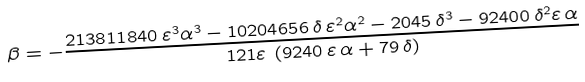Convert formula to latex. <formula><loc_0><loc_0><loc_500><loc_500>\beta = - { \frac { 2 1 3 8 1 1 8 4 0 \, { \varepsilon } ^ { 3 } { \alpha } ^ { 3 } - 1 0 2 0 4 6 5 6 \, \delta \, { \varepsilon } ^ { 2 } { \alpha } ^ { 2 } - 2 0 4 5 \, { \delta } ^ { 3 } - 9 2 4 0 0 \, { \delta } ^ { 2 } \varepsilon \, \alpha } { 1 2 1 \varepsilon \, \left ( 9 2 4 0 \, \varepsilon \, \alpha + 7 9 \, \delta \right ) } }</formula> 